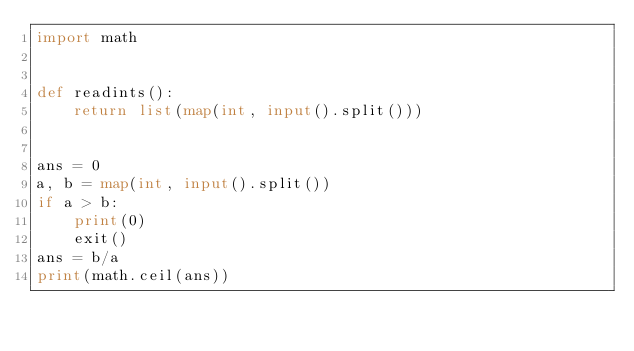<code> <loc_0><loc_0><loc_500><loc_500><_Python_>import math


def readints():
    return list(map(int, input().split()))


ans = 0
a, b = map(int, input().split())
if a > b:
    print(0)
    exit()
ans = b/a
print(math.ceil(ans))
</code> 